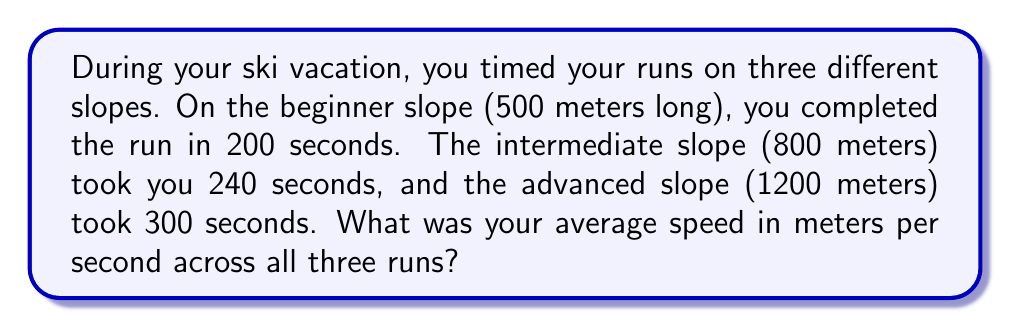Could you help me with this problem? Let's approach this step-by-step:

1. Calculate the speed for each run:
   - Beginner slope: $s_1 = \frac{distance}{time} = \frac{500\text{ m}}{200\text{ s}} = 2.5\text{ m/s}$
   - Intermediate slope: $s_2 = \frac{800\text{ m}}{240\text{ s}} = 3.33\text{ m/s}$
   - Advanced slope: $s_3 = \frac{1200\text{ m}}{300\text{ s}} = 4\text{ m/s}$

2. To find the average speed, we need to consider the total distance and total time:
   - Total distance: $d_{total} = 500\text{ m} + 800\text{ m} + 1200\text{ m} = 2500\text{ m}$
   - Total time: $t_{total} = 200\text{ s} + 240\text{ s} + 300\text{ s} = 740\text{ s}$

3. Calculate the average speed:
   $$s_{avg} = \frac{d_{total}}{t_{total}} = \frac{2500\text{ m}}{740\text{ s}} \approx 3.38\text{ m/s}$$

Note: This method gives the correct average speed, as it takes into account the different distances of each run. Simply averaging the three individual speeds would not be accurate in this case.
Answer: $3.38\text{ m/s}$ 